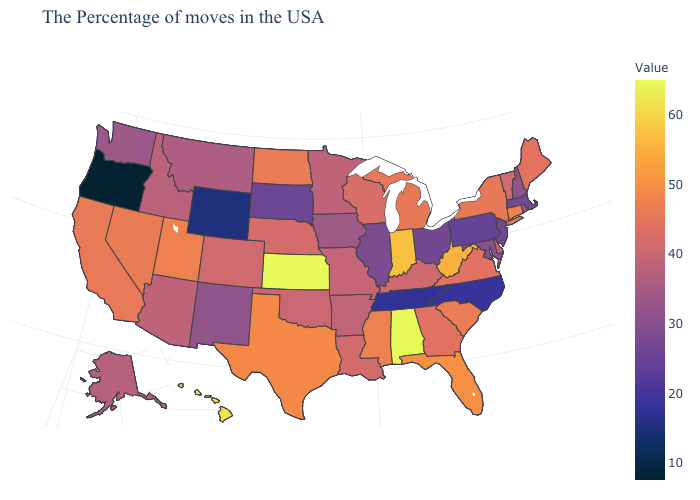Does Alaska have the lowest value in the West?
Give a very brief answer. No. Among the states that border Oregon , which have the lowest value?
Short answer required. Washington. Does Tennessee have the lowest value in the South?
Quick response, please. Yes. Does Hawaii have the highest value in the West?
Answer briefly. Yes. Which states have the lowest value in the West?
Answer briefly. Oregon. Does Kansas have the highest value in the MidWest?
Answer briefly. Yes. Is the legend a continuous bar?
Quick response, please. Yes. 